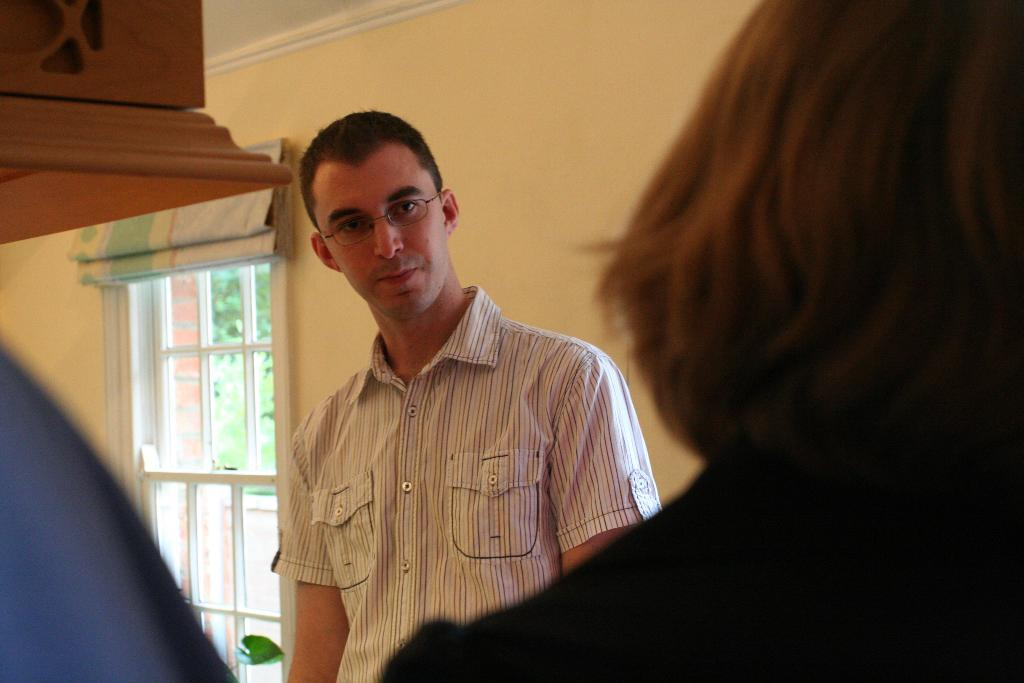What is the man doing in the image? The man is standing inside the house. Who is in front of the man? There is a woman in front of the man. What can be seen in the background of the image? There is a wall with a window in the background. What type of window treatment is present in the image? There are curtains on top of the window. What type of birthday trick is the man performing in the image? There is no indication of a birthday or a trick in the image; it simply shows a man standing inside the house with a woman in front of him and a window with curtains in the background. 